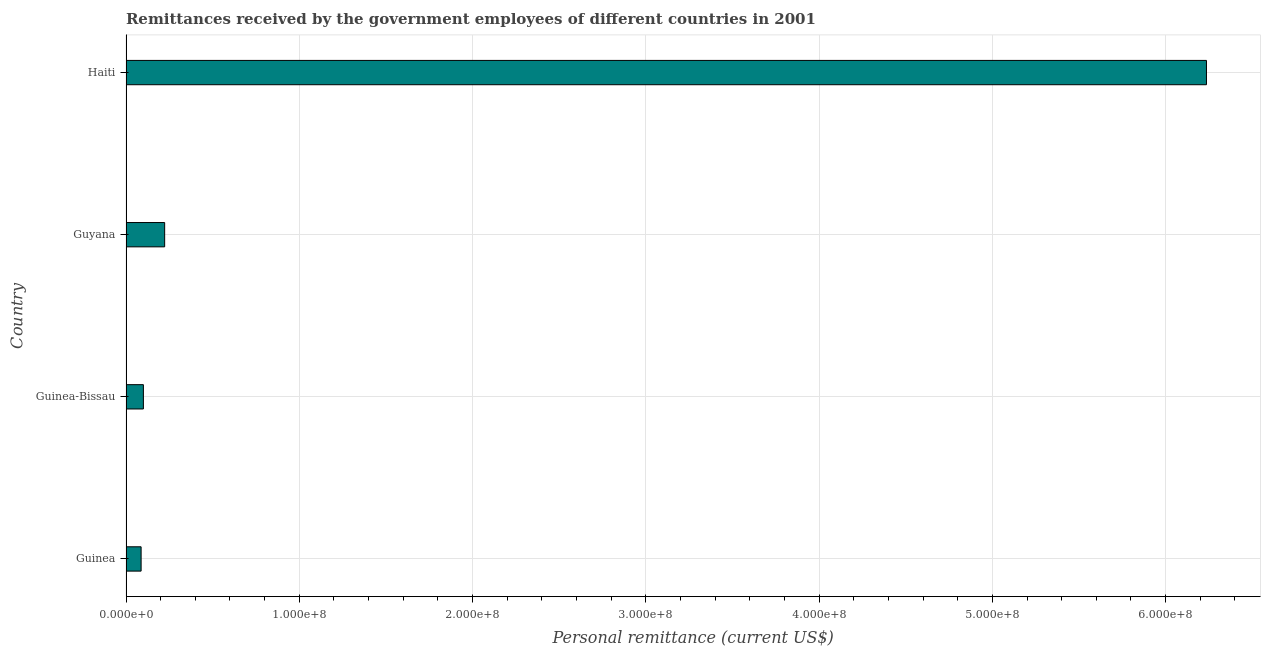What is the title of the graph?
Offer a terse response. Remittances received by the government employees of different countries in 2001. What is the label or title of the X-axis?
Offer a terse response. Personal remittance (current US$). What is the label or title of the Y-axis?
Provide a succinct answer. Country. What is the personal remittances in Haiti?
Offer a very short reply. 6.24e+08. Across all countries, what is the maximum personal remittances?
Your answer should be very brief. 6.24e+08. Across all countries, what is the minimum personal remittances?
Your response must be concise. 8.72e+06. In which country was the personal remittances maximum?
Your response must be concise. Haiti. In which country was the personal remittances minimum?
Make the answer very short. Guinea. What is the sum of the personal remittances?
Give a very brief answer. 6.65e+08. What is the difference between the personal remittances in Guinea-Bissau and Haiti?
Make the answer very short. -6.14e+08. What is the average personal remittances per country?
Offer a very short reply. 1.66e+08. What is the median personal remittances?
Make the answer very short. 1.62e+07. What is the ratio of the personal remittances in Guinea to that in Guyana?
Offer a very short reply. 0.39. Is the personal remittances in Guyana less than that in Haiti?
Keep it short and to the point. Yes. What is the difference between the highest and the second highest personal remittances?
Keep it short and to the point. 6.01e+08. What is the difference between the highest and the lowest personal remittances?
Your answer should be very brief. 6.15e+08. How many bars are there?
Your answer should be compact. 4. Are all the bars in the graph horizontal?
Your response must be concise. Yes. How many countries are there in the graph?
Provide a short and direct response. 4. What is the difference between two consecutive major ticks on the X-axis?
Give a very brief answer. 1.00e+08. What is the Personal remittance (current US$) of Guinea?
Offer a very short reply. 8.72e+06. What is the Personal remittance (current US$) in Guinea-Bissau?
Offer a very short reply. 1.00e+07. What is the Personal remittance (current US$) in Guyana?
Your answer should be compact. 2.23e+07. What is the Personal remittance (current US$) of Haiti?
Keep it short and to the point. 6.24e+08. What is the difference between the Personal remittance (current US$) in Guinea and Guinea-Bissau?
Your answer should be very brief. -1.31e+06. What is the difference between the Personal remittance (current US$) in Guinea and Guyana?
Your answer should be very brief. -1.36e+07. What is the difference between the Personal remittance (current US$) in Guinea and Haiti?
Provide a short and direct response. -6.15e+08. What is the difference between the Personal remittance (current US$) in Guinea-Bissau and Guyana?
Provide a short and direct response. -1.23e+07. What is the difference between the Personal remittance (current US$) in Guinea-Bissau and Haiti?
Make the answer very short. -6.14e+08. What is the difference between the Personal remittance (current US$) in Guyana and Haiti?
Offer a terse response. -6.01e+08. What is the ratio of the Personal remittance (current US$) in Guinea to that in Guinea-Bissau?
Offer a very short reply. 0.87. What is the ratio of the Personal remittance (current US$) in Guinea to that in Guyana?
Keep it short and to the point. 0.39. What is the ratio of the Personal remittance (current US$) in Guinea to that in Haiti?
Your response must be concise. 0.01. What is the ratio of the Personal remittance (current US$) in Guinea-Bissau to that in Guyana?
Your response must be concise. 0.45. What is the ratio of the Personal remittance (current US$) in Guinea-Bissau to that in Haiti?
Give a very brief answer. 0.02. What is the ratio of the Personal remittance (current US$) in Guyana to that in Haiti?
Your response must be concise. 0.04. 